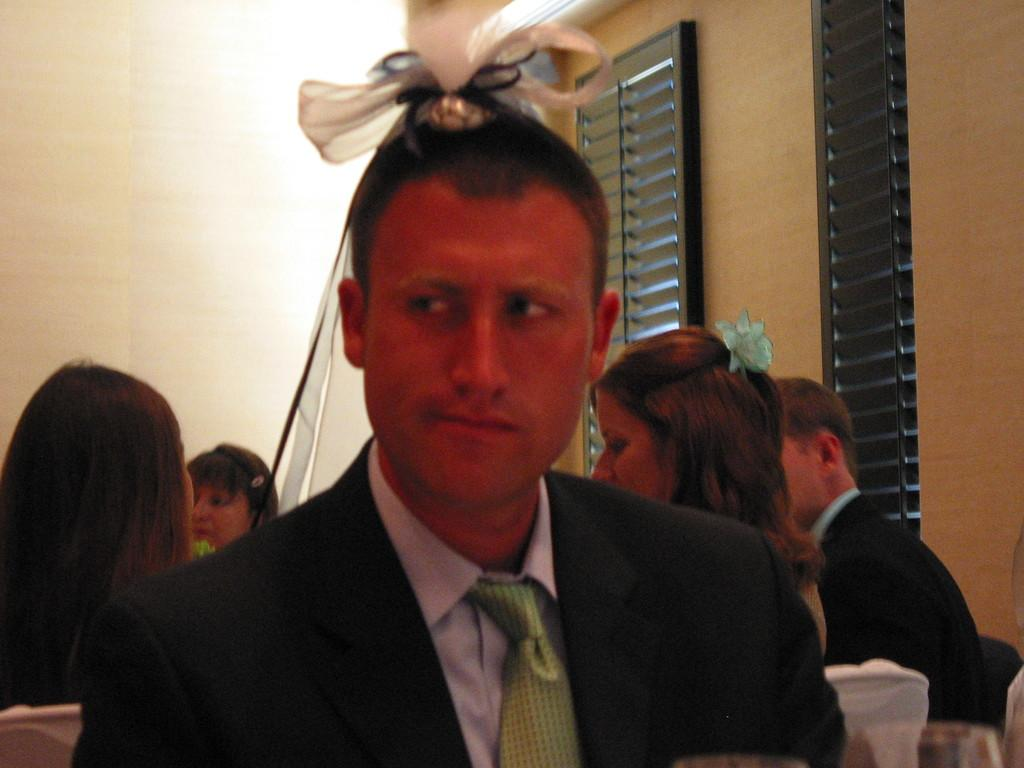What is happening in the room in the image? There are people sitting in a room. Can you describe the person at the front of the room? The person at the front is wearing a suit and has a band on his head. Where are the window blinds located in the room? The window blinds are at the right back of the room. How many shoes are visible on the floor in the image? There is no mention of shoes in the image, so we cannot determine how many are visible. What type of worm can be seen crawling on the person at the front of the room? There is no worm present in the image; the person at the front is wearing a suit and has a band on his head. 